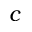<formula> <loc_0><loc_0><loc_500><loc_500>c</formula> 